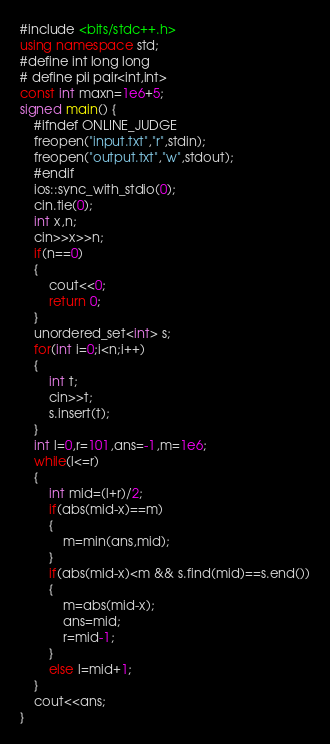Convert code to text. <code><loc_0><loc_0><loc_500><loc_500><_C++_>#include <bits/stdc++.h> 
using namespace std; 
#define int long long
# define pii pair<int,int>
const int maxn=1e6+5;
signed main() { 
    #ifndef ONLINE_JUDGE
    freopen("input.txt","r",stdin);
    freopen("output.txt","w",stdout);
    #endif
    ios::sync_with_stdio(0);
    cin.tie(0);
    int x,n;
    cin>>x>>n;
    if(n==0)
    {
    	cout<<0;
    	return 0;
    }
    unordered_set<int> s;
    for(int i=0;i<n;i++)
    {
    	int t;
    	cin>>t;
    	s.insert(t);
    }
    int l=0,r=101,ans=-1,m=1e6;
    while(l<=r)
    {
    	int mid=(l+r)/2;
    	if(abs(mid-x)==m)
    	{
    		m=min(ans,mid);
    	}
    	if(abs(mid-x)<m && s.find(mid)==s.end())
    	{
    		m=abs(mid-x);
    		ans=mid;
    		r=mid-1;
    	}
    	else l=mid+1;
    }
    cout<<ans;
}</code> 